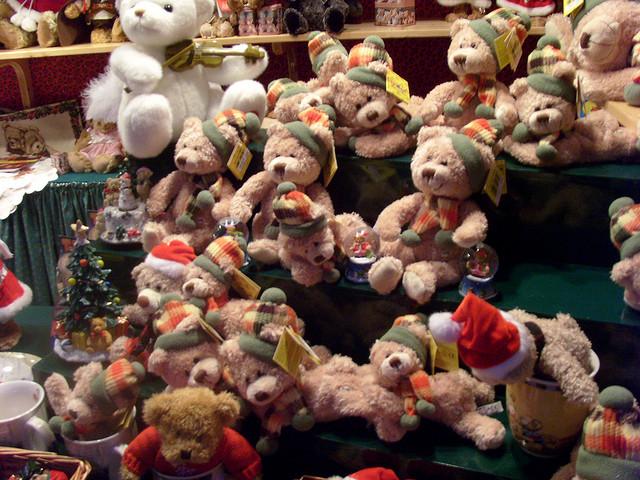Where are these dolls sold?
Concise answer only. Toy store. How many bears are there?
Quick response, please. 23. What holiday do these represent?
Write a very short answer. Christmas. 